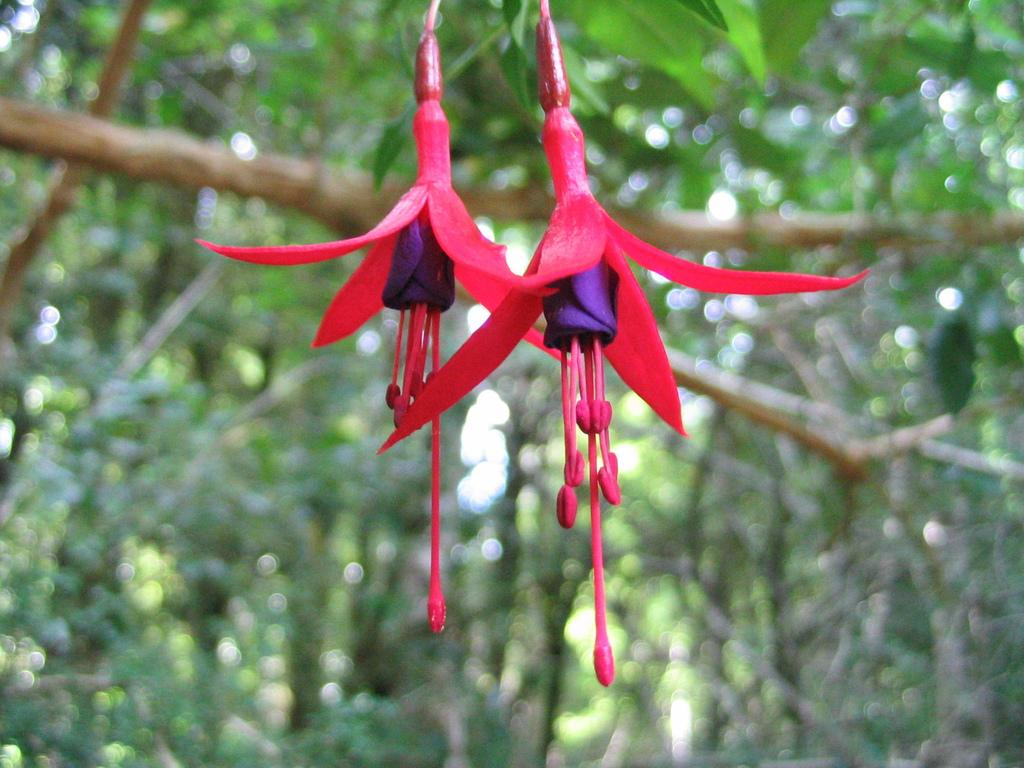What is: What is the main subject in the center of the image? There are flowers in the center of the image. What can be seen in the background of the image? There are trees in the background of the image. What type of sofa can be seen in the image? There is no sofa present in the image; it features flowers in the center and trees in the background. 